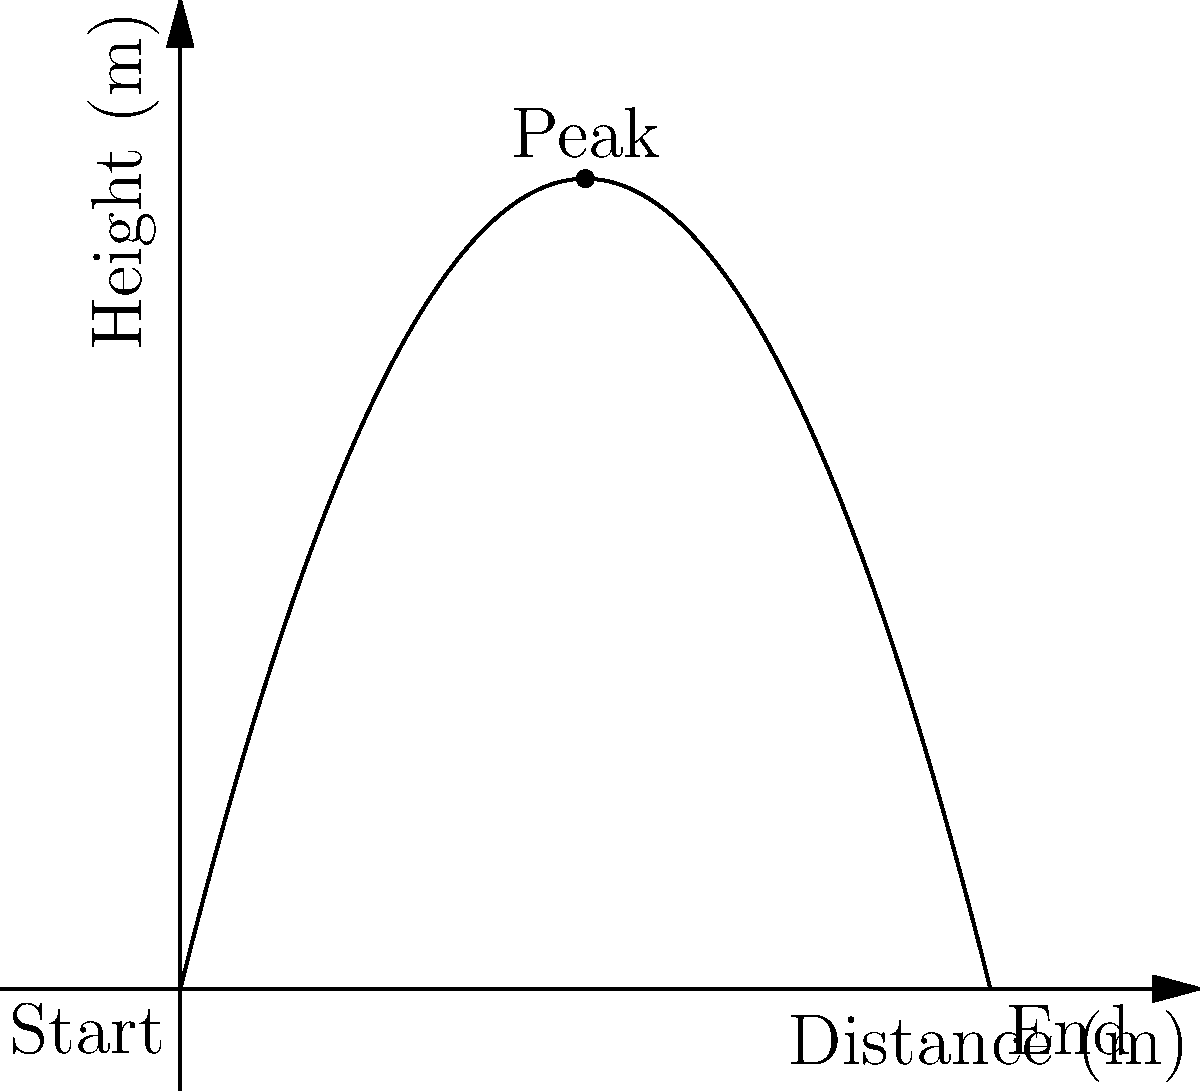As a gymnast, you're analyzing the trajectory of your flip for a painting inspiration. The path of your flip can be modeled by the function $h(x) = -0.5x^2 + 4x$, where $h$ is the height in meters and $x$ is the horizontal distance in meters. What is the maximum height you reach during your flip? To find the maximum height of the flip, we need to follow these steps:

1) The maximum height occurs at the vertex of the parabola.

2) For a quadratic function in the form $f(x) = ax^2 + bx + c$, the x-coordinate of the vertex is given by $x = -\frac{b}{2a}$.

3) In our function $h(x) = -0.5x^2 + 4x$, we have $a = -0.5$ and $b = 4$.

4) Substituting these values:
   $x = -\frac{4}{2(-0.5)} = -\frac{4}{-1} = 4$

5) To find the maximum height, we need to calculate $h(4)$:
   $h(4) = -0.5(4)^2 + 4(4)$
         $= -0.5(16) + 16$
         $= -8 + 16$
         $= 8$

Therefore, the maximum height reached during the flip is 8 meters.
Answer: 8 meters 